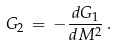<formula> <loc_0><loc_0><loc_500><loc_500>G _ { 2 } \, = \, - \frac { d G _ { 1 } } { d M ^ { 2 } } \, .</formula> 